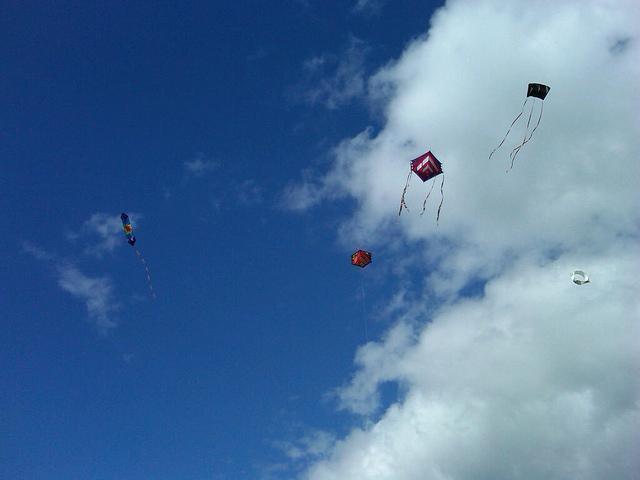How many kites are in the sky?
Give a very brief answer. 5. 